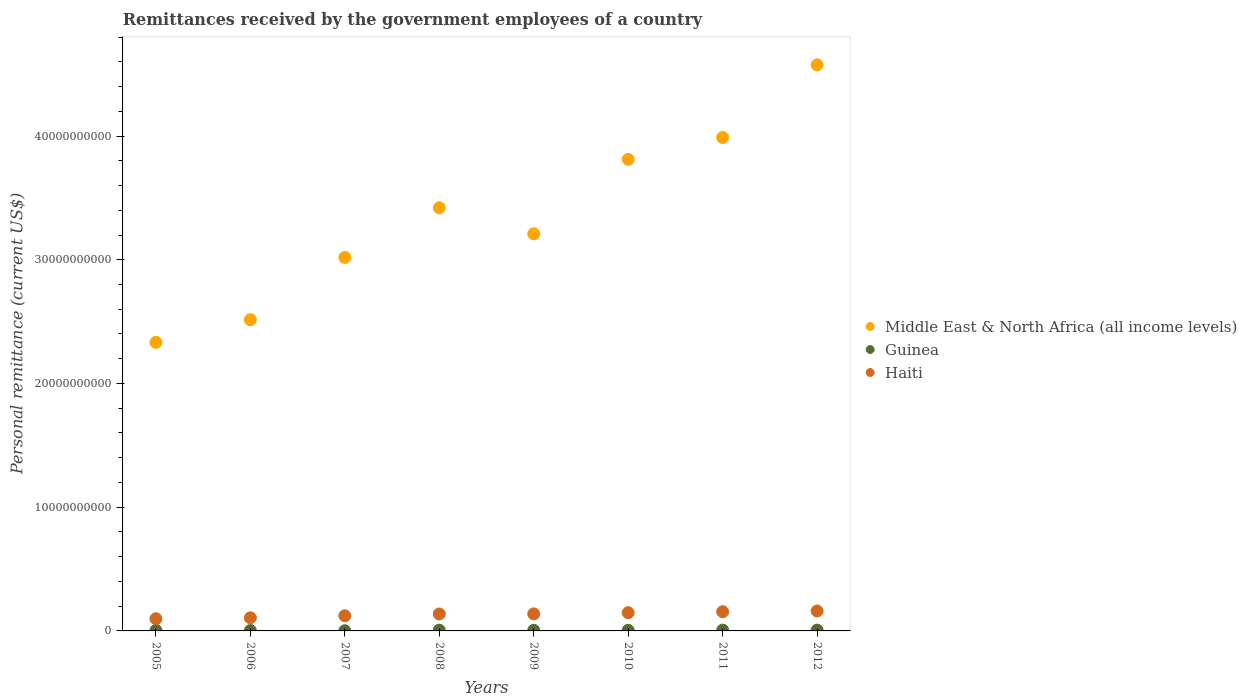What is the remittances received by the government employees in Middle East & North Africa (all income levels) in 2010?
Your answer should be very brief. 3.81e+1. Across all years, what is the maximum remittances received by the government employees in Haiti?
Offer a terse response. 1.61e+09. Across all years, what is the minimum remittances received by the government employees in Guinea?
Make the answer very short. 1.51e+07. In which year was the remittances received by the government employees in Middle East & North Africa (all income levels) maximum?
Keep it short and to the point. 2012. What is the total remittances received by the government employees in Haiti in the graph?
Your answer should be compact. 1.07e+1. What is the difference between the remittances received by the government employees in Middle East & North Africa (all income levels) in 2006 and that in 2008?
Provide a short and direct response. -9.05e+09. What is the difference between the remittances received by the government employees in Middle East & North Africa (all income levels) in 2012 and the remittances received by the government employees in Guinea in 2007?
Give a very brief answer. 4.57e+1. What is the average remittances received by the government employees in Guinea per year?
Provide a short and direct response. 4.71e+07. In the year 2010, what is the difference between the remittances received by the government employees in Guinea and remittances received by the government employees in Middle East & North Africa (all income levels)?
Offer a terse response. -3.81e+1. In how many years, is the remittances received by the government employees in Haiti greater than 28000000000 US$?
Offer a very short reply. 0. What is the ratio of the remittances received by the government employees in Guinea in 2007 to that in 2008?
Provide a succinct answer. 0.24. Is the remittances received by the government employees in Haiti in 2006 less than that in 2009?
Provide a short and direct response. Yes. Is the difference between the remittances received by the government employees in Guinea in 2009 and 2010 greater than the difference between the remittances received by the government employees in Middle East & North Africa (all income levels) in 2009 and 2010?
Ensure brevity in your answer.  Yes. What is the difference between the highest and the second highest remittances received by the government employees in Guinea?
Give a very brief answer. 1.80e+06. What is the difference between the highest and the lowest remittances received by the government employees in Middle East & North Africa (all income levels)?
Provide a succinct answer. 2.24e+1. Is the remittances received by the government employees in Guinea strictly greater than the remittances received by the government employees in Middle East & North Africa (all income levels) over the years?
Your response must be concise. No. How many dotlines are there?
Keep it short and to the point. 3. Does the graph contain any zero values?
Give a very brief answer. No. Does the graph contain grids?
Offer a terse response. No. How many legend labels are there?
Your response must be concise. 3. What is the title of the graph?
Make the answer very short. Remittances received by the government employees of a country. What is the label or title of the X-axis?
Your answer should be very brief. Years. What is the label or title of the Y-axis?
Your answer should be compact. Personal remittance (current US$). What is the Personal remittance (current US$) of Middle East & North Africa (all income levels) in 2005?
Make the answer very short. 2.33e+1. What is the Personal remittance (current US$) of Guinea in 2005?
Provide a succinct answer. 4.16e+07. What is the Personal remittance (current US$) of Haiti in 2005?
Keep it short and to the point. 9.86e+08. What is the Personal remittance (current US$) of Middle East & North Africa (all income levels) in 2006?
Your response must be concise. 2.52e+1. What is the Personal remittance (current US$) in Guinea in 2006?
Your response must be concise. 2.95e+07. What is the Personal remittance (current US$) of Haiti in 2006?
Provide a short and direct response. 1.06e+09. What is the Personal remittance (current US$) in Middle East & North Africa (all income levels) in 2007?
Your response must be concise. 3.02e+1. What is the Personal remittance (current US$) of Guinea in 2007?
Provide a short and direct response. 1.51e+07. What is the Personal remittance (current US$) of Haiti in 2007?
Give a very brief answer. 1.22e+09. What is the Personal remittance (current US$) in Middle East & North Africa (all income levels) in 2008?
Provide a short and direct response. 3.42e+1. What is the Personal remittance (current US$) of Guinea in 2008?
Provide a short and direct response. 6.15e+07. What is the Personal remittance (current US$) of Haiti in 2008?
Make the answer very short. 1.37e+09. What is the Personal remittance (current US$) of Middle East & North Africa (all income levels) in 2009?
Provide a short and direct response. 3.21e+1. What is the Personal remittance (current US$) of Guinea in 2009?
Ensure brevity in your answer.  5.20e+07. What is the Personal remittance (current US$) in Haiti in 2009?
Offer a very short reply. 1.38e+09. What is the Personal remittance (current US$) in Middle East & North Africa (all income levels) in 2010?
Your response must be concise. 3.81e+1. What is the Personal remittance (current US$) of Guinea in 2010?
Make the answer very short. 4.63e+07. What is the Personal remittance (current US$) of Haiti in 2010?
Keep it short and to the point. 1.47e+09. What is the Personal remittance (current US$) of Middle East & North Africa (all income levels) in 2011?
Offer a very short reply. 3.99e+1. What is the Personal remittance (current US$) of Guinea in 2011?
Your answer should be compact. 6.45e+07. What is the Personal remittance (current US$) in Haiti in 2011?
Your answer should be very brief. 1.55e+09. What is the Personal remittance (current US$) of Middle East & North Africa (all income levels) in 2012?
Make the answer very short. 4.58e+1. What is the Personal remittance (current US$) in Guinea in 2012?
Provide a short and direct response. 6.63e+07. What is the Personal remittance (current US$) of Haiti in 2012?
Offer a very short reply. 1.61e+09. Across all years, what is the maximum Personal remittance (current US$) in Middle East & North Africa (all income levels)?
Offer a terse response. 4.58e+1. Across all years, what is the maximum Personal remittance (current US$) in Guinea?
Make the answer very short. 6.63e+07. Across all years, what is the maximum Personal remittance (current US$) of Haiti?
Offer a very short reply. 1.61e+09. Across all years, what is the minimum Personal remittance (current US$) of Middle East & North Africa (all income levels)?
Ensure brevity in your answer.  2.33e+1. Across all years, what is the minimum Personal remittance (current US$) of Guinea?
Offer a very short reply. 1.51e+07. Across all years, what is the minimum Personal remittance (current US$) of Haiti?
Offer a terse response. 9.86e+08. What is the total Personal remittance (current US$) in Middle East & North Africa (all income levels) in the graph?
Your answer should be compact. 2.69e+11. What is the total Personal remittance (current US$) in Guinea in the graph?
Your answer should be compact. 3.77e+08. What is the total Personal remittance (current US$) in Haiti in the graph?
Your answer should be compact. 1.07e+1. What is the difference between the Personal remittance (current US$) of Middle East & North Africa (all income levels) in 2005 and that in 2006?
Your answer should be very brief. -1.83e+09. What is the difference between the Personal remittance (current US$) in Guinea in 2005 and that in 2006?
Provide a short and direct response. 1.21e+07. What is the difference between the Personal remittance (current US$) in Haiti in 2005 and that in 2006?
Provide a short and direct response. -7.67e+07. What is the difference between the Personal remittance (current US$) of Middle East & North Africa (all income levels) in 2005 and that in 2007?
Offer a very short reply. -6.86e+09. What is the difference between the Personal remittance (current US$) in Guinea in 2005 and that in 2007?
Ensure brevity in your answer.  2.65e+07. What is the difference between the Personal remittance (current US$) in Haiti in 2005 and that in 2007?
Ensure brevity in your answer.  -2.36e+08. What is the difference between the Personal remittance (current US$) in Middle East & North Africa (all income levels) in 2005 and that in 2008?
Your answer should be very brief. -1.09e+1. What is the difference between the Personal remittance (current US$) in Guinea in 2005 and that in 2008?
Offer a terse response. -2.00e+07. What is the difference between the Personal remittance (current US$) of Haiti in 2005 and that in 2008?
Make the answer very short. -3.84e+08. What is the difference between the Personal remittance (current US$) in Middle East & North Africa (all income levels) in 2005 and that in 2009?
Your answer should be very brief. -8.77e+09. What is the difference between the Personal remittance (current US$) of Guinea in 2005 and that in 2009?
Provide a succinct answer. -1.05e+07. What is the difference between the Personal remittance (current US$) of Haiti in 2005 and that in 2009?
Give a very brief answer. -3.89e+08. What is the difference between the Personal remittance (current US$) in Middle East & North Africa (all income levels) in 2005 and that in 2010?
Provide a succinct answer. -1.48e+1. What is the difference between the Personal remittance (current US$) in Guinea in 2005 and that in 2010?
Offer a terse response. -4.69e+06. What is the difference between the Personal remittance (current US$) in Haiti in 2005 and that in 2010?
Keep it short and to the point. -4.88e+08. What is the difference between the Personal remittance (current US$) of Middle East & North Africa (all income levels) in 2005 and that in 2011?
Provide a succinct answer. -1.66e+1. What is the difference between the Personal remittance (current US$) of Guinea in 2005 and that in 2011?
Your response must be concise. -2.29e+07. What is the difference between the Personal remittance (current US$) in Haiti in 2005 and that in 2011?
Your answer should be very brief. -5.65e+08. What is the difference between the Personal remittance (current US$) in Middle East & North Africa (all income levels) in 2005 and that in 2012?
Make the answer very short. -2.24e+1. What is the difference between the Personal remittance (current US$) of Guinea in 2005 and that in 2012?
Offer a very short reply. -2.47e+07. What is the difference between the Personal remittance (current US$) in Haiti in 2005 and that in 2012?
Keep it short and to the point. -6.26e+08. What is the difference between the Personal remittance (current US$) in Middle East & North Africa (all income levels) in 2006 and that in 2007?
Give a very brief answer. -5.03e+09. What is the difference between the Personal remittance (current US$) in Guinea in 2006 and that in 2007?
Keep it short and to the point. 1.44e+07. What is the difference between the Personal remittance (current US$) of Haiti in 2006 and that in 2007?
Offer a very short reply. -1.59e+08. What is the difference between the Personal remittance (current US$) of Middle East & North Africa (all income levels) in 2006 and that in 2008?
Provide a short and direct response. -9.05e+09. What is the difference between the Personal remittance (current US$) of Guinea in 2006 and that in 2008?
Your answer should be very brief. -3.20e+07. What is the difference between the Personal remittance (current US$) in Haiti in 2006 and that in 2008?
Make the answer very short. -3.07e+08. What is the difference between the Personal remittance (current US$) in Middle East & North Africa (all income levels) in 2006 and that in 2009?
Provide a succinct answer. -6.95e+09. What is the difference between the Personal remittance (current US$) in Guinea in 2006 and that in 2009?
Your response must be concise. -2.25e+07. What is the difference between the Personal remittance (current US$) of Haiti in 2006 and that in 2009?
Your answer should be compact. -3.13e+08. What is the difference between the Personal remittance (current US$) in Middle East & North Africa (all income levels) in 2006 and that in 2010?
Ensure brevity in your answer.  -1.30e+1. What is the difference between the Personal remittance (current US$) in Guinea in 2006 and that in 2010?
Your answer should be very brief. -1.68e+07. What is the difference between the Personal remittance (current US$) in Haiti in 2006 and that in 2010?
Your answer should be compact. -4.11e+08. What is the difference between the Personal remittance (current US$) of Middle East & North Africa (all income levels) in 2006 and that in 2011?
Offer a terse response. -1.47e+1. What is the difference between the Personal remittance (current US$) in Guinea in 2006 and that in 2011?
Offer a terse response. -3.50e+07. What is the difference between the Personal remittance (current US$) in Haiti in 2006 and that in 2011?
Provide a succinct answer. -4.88e+08. What is the difference between the Personal remittance (current US$) of Middle East & North Africa (all income levels) in 2006 and that in 2012?
Your response must be concise. -2.06e+1. What is the difference between the Personal remittance (current US$) of Guinea in 2006 and that in 2012?
Your answer should be very brief. -3.68e+07. What is the difference between the Personal remittance (current US$) in Haiti in 2006 and that in 2012?
Keep it short and to the point. -5.49e+08. What is the difference between the Personal remittance (current US$) of Middle East & North Africa (all income levels) in 2007 and that in 2008?
Provide a succinct answer. -4.01e+09. What is the difference between the Personal remittance (current US$) in Guinea in 2007 and that in 2008?
Keep it short and to the point. -4.64e+07. What is the difference between the Personal remittance (current US$) of Haiti in 2007 and that in 2008?
Your answer should be very brief. -1.48e+08. What is the difference between the Personal remittance (current US$) in Middle East & North Africa (all income levels) in 2007 and that in 2009?
Ensure brevity in your answer.  -1.91e+09. What is the difference between the Personal remittance (current US$) in Guinea in 2007 and that in 2009?
Provide a succinct answer. -3.70e+07. What is the difference between the Personal remittance (current US$) of Haiti in 2007 and that in 2009?
Provide a short and direct response. -1.53e+08. What is the difference between the Personal remittance (current US$) in Middle East & North Africa (all income levels) in 2007 and that in 2010?
Keep it short and to the point. -7.93e+09. What is the difference between the Personal remittance (current US$) in Guinea in 2007 and that in 2010?
Make the answer very short. -3.12e+07. What is the difference between the Personal remittance (current US$) of Haiti in 2007 and that in 2010?
Ensure brevity in your answer.  -2.52e+08. What is the difference between the Personal remittance (current US$) in Middle East & North Africa (all income levels) in 2007 and that in 2011?
Provide a succinct answer. -9.70e+09. What is the difference between the Personal remittance (current US$) of Guinea in 2007 and that in 2011?
Offer a terse response. -4.94e+07. What is the difference between the Personal remittance (current US$) of Haiti in 2007 and that in 2011?
Your answer should be very brief. -3.29e+08. What is the difference between the Personal remittance (current US$) in Middle East & North Africa (all income levels) in 2007 and that in 2012?
Offer a terse response. -1.56e+1. What is the difference between the Personal remittance (current US$) of Guinea in 2007 and that in 2012?
Your response must be concise. -5.12e+07. What is the difference between the Personal remittance (current US$) of Haiti in 2007 and that in 2012?
Provide a short and direct response. -3.90e+08. What is the difference between the Personal remittance (current US$) in Middle East & North Africa (all income levels) in 2008 and that in 2009?
Your answer should be very brief. 2.10e+09. What is the difference between the Personal remittance (current US$) in Guinea in 2008 and that in 2009?
Provide a succinct answer. 9.49e+06. What is the difference between the Personal remittance (current US$) of Haiti in 2008 and that in 2009?
Ensure brevity in your answer.  -5.79e+06. What is the difference between the Personal remittance (current US$) in Middle East & North Africa (all income levels) in 2008 and that in 2010?
Ensure brevity in your answer.  -3.91e+09. What is the difference between the Personal remittance (current US$) in Guinea in 2008 and that in 2010?
Offer a very short reply. 1.53e+07. What is the difference between the Personal remittance (current US$) in Haiti in 2008 and that in 2010?
Your response must be concise. -1.04e+08. What is the difference between the Personal remittance (current US$) in Middle East & North Africa (all income levels) in 2008 and that in 2011?
Give a very brief answer. -5.68e+09. What is the difference between the Personal remittance (current US$) in Guinea in 2008 and that in 2011?
Ensure brevity in your answer.  -2.98e+06. What is the difference between the Personal remittance (current US$) in Haiti in 2008 and that in 2011?
Your answer should be very brief. -1.82e+08. What is the difference between the Personal remittance (current US$) in Middle East & North Africa (all income levels) in 2008 and that in 2012?
Your answer should be compact. -1.16e+1. What is the difference between the Personal remittance (current US$) of Guinea in 2008 and that in 2012?
Provide a short and direct response. -4.78e+06. What is the difference between the Personal remittance (current US$) of Haiti in 2008 and that in 2012?
Offer a terse response. -2.43e+08. What is the difference between the Personal remittance (current US$) of Middle East & North Africa (all income levels) in 2009 and that in 2010?
Offer a terse response. -6.02e+09. What is the difference between the Personal remittance (current US$) in Guinea in 2009 and that in 2010?
Provide a succinct answer. 5.77e+06. What is the difference between the Personal remittance (current US$) in Haiti in 2009 and that in 2010?
Offer a terse response. -9.83e+07. What is the difference between the Personal remittance (current US$) of Middle East & North Africa (all income levels) in 2009 and that in 2011?
Provide a succinct answer. -7.79e+09. What is the difference between the Personal remittance (current US$) in Guinea in 2009 and that in 2011?
Your answer should be compact. -1.25e+07. What is the difference between the Personal remittance (current US$) of Haiti in 2009 and that in 2011?
Ensure brevity in your answer.  -1.76e+08. What is the difference between the Personal remittance (current US$) in Middle East & North Africa (all income levels) in 2009 and that in 2012?
Make the answer very short. -1.37e+1. What is the difference between the Personal remittance (current US$) of Guinea in 2009 and that in 2012?
Your answer should be compact. -1.43e+07. What is the difference between the Personal remittance (current US$) of Haiti in 2009 and that in 2012?
Make the answer very short. -2.37e+08. What is the difference between the Personal remittance (current US$) of Middle East & North Africa (all income levels) in 2010 and that in 2011?
Your answer should be very brief. -1.77e+09. What is the difference between the Personal remittance (current US$) in Guinea in 2010 and that in 2011?
Your answer should be compact. -1.82e+07. What is the difference between the Personal remittance (current US$) in Haiti in 2010 and that in 2011?
Make the answer very short. -7.76e+07. What is the difference between the Personal remittance (current US$) of Middle East & North Africa (all income levels) in 2010 and that in 2012?
Ensure brevity in your answer.  -7.64e+09. What is the difference between the Personal remittance (current US$) of Guinea in 2010 and that in 2012?
Make the answer very short. -2.00e+07. What is the difference between the Personal remittance (current US$) of Haiti in 2010 and that in 2012?
Provide a succinct answer. -1.39e+08. What is the difference between the Personal remittance (current US$) in Middle East & North Africa (all income levels) in 2011 and that in 2012?
Ensure brevity in your answer.  -5.87e+09. What is the difference between the Personal remittance (current US$) in Guinea in 2011 and that in 2012?
Your response must be concise. -1.80e+06. What is the difference between the Personal remittance (current US$) in Haiti in 2011 and that in 2012?
Give a very brief answer. -6.10e+07. What is the difference between the Personal remittance (current US$) of Middle East & North Africa (all income levels) in 2005 and the Personal remittance (current US$) of Guinea in 2006?
Ensure brevity in your answer.  2.33e+1. What is the difference between the Personal remittance (current US$) in Middle East & North Africa (all income levels) in 2005 and the Personal remittance (current US$) in Haiti in 2006?
Make the answer very short. 2.23e+1. What is the difference between the Personal remittance (current US$) in Guinea in 2005 and the Personal remittance (current US$) in Haiti in 2006?
Keep it short and to the point. -1.02e+09. What is the difference between the Personal remittance (current US$) in Middle East & North Africa (all income levels) in 2005 and the Personal remittance (current US$) in Guinea in 2007?
Offer a terse response. 2.33e+1. What is the difference between the Personal remittance (current US$) in Middle East & North Africa (all income levels) in 2005 and the Personal remittance (current US$) in Haiti in 2007?
Offer a very short reply. 2.21e+1. What is the difference between the Personal remittance (current US$) of Guinea in 2005 and the Personal remittance (current US$) of Haiti in 2007?
Offer a very short reply. -1.18e+09. What is the difference between the Personal remittance (current US$) in Middle East & North Africa (all income levels) in 2005 and the Personal remittance (current US$) in Guinea in 2008?
Your response must be concise. 2.33e+1. What is the difference between the Personal remittance (current US$) of Middle East & North Africa (all income levels) in 2005 and the Personal remittance (current US$) of Haiti in 2008?
Your answer should be compact. 2.20e+1. What is the difference between the Personal remittance (current US$) in Guinea in 2005 and the Personal remittance (current US$) in Haiti in 2008?
Keep it short and to the point. -1.33e+09. What is the difference between the Personal remittance (current US$) in Middle East & North Africa (all income levels) in 2005 and the Personal remittance (current US$) in Guinea in 2009?
Keep it short and to the point. 2.33e+1. What is the difference between the Personal remittance (current US$) in Middle East & North Africa (all income levels) in 2005 and the Personal remittance (current US$) in Haiti in 2009?
Provide a succinct answer. 2.20e+1. What is the difference between the Personal remittance (current US$) in Guinea in 2005 and the Personal remittance (current US$) in Haiti in 2009?
Offer a very short reply. -1.33e+09. What is the difference between the Personal remittance (current US$) in Middle East & North Africa (all income levels) in 2005 and the Personal remittance (current US$) in Guinea in 2010?
Make the answer very short. 2.33e+1. What is the difference between the Personal remittance (current US$) in Middle East & North Africa (all income levels) in 2005 and the Personal remittance (current US$) in Haiti in 2010?
Give a very brief answer. 2.19e+1. What is the difference between the Personal remittance (current US$) of Guinea in 2005 and the Personal remittance (current US$) of Haiti in 2010?
Offer a terse response. -1.43e+09. What is the difference between the Personal remittance (current US$) in Middle East & North Africa (all income levels) in 2005 and the Personal remittance (current US$) in Guinea in 2011?
Provide a short and direct response. 2.33e+1. What is the difference between the Personal remittance (current US$) in Middle East & North Africa (all income levels) in 2005 and the Personal remittance (current US$) in Haiti in 2011?
Your response must be concise. 2.18e+1. What is the difference between the Personal remittance (current US$) in Guinea in 2005 and the Personal remittance (current US$) in Haiti in 2011?
Your answer should be very brief. -1.51e+09. What is the difference between the Personal remittance (current US$) in Middle East & North Africa (all income levels) in 2005 and the Personal remittance (current US$) in Guinea in 2012?
Ensure brevity in your answer.  2.33e+1. What is the difference between the Personal remittance (current US$) of Middle East & North Africa (all income levels) in 2005 and the Personal remittance (current US$) of Haiti in 2012?
Your answer should be very brief. 2.17e+1. What is the difference between the Personal remittance (current US$) of Guinea in 2005 and the Personal remittance (current US$) of Haiti in 2012?
Offer a very short reply. -1.57e+09. What is the difference between the Personal remittance (current US$) in Middle East & North Africa (all income levels) in 2006 and the Personal remittance (current US$) in Guinea in 2007?
Offer a very short reply. 2.51e+1. What is the difference between the Personal remittance (current US$) of Middle East & North Africa (all income levels) in 2006 and the Personal remittance (current US$) of Haiti in 2007?
Offer a terse response. 2.39e+1. What is the difference between the Personal remittance (current US$) in Guinea in 2006 and the Personal remittance (current US$) in Haiti in 2007?
Give a very brief answer. -1.19e+09. What is the difference between the Personal remittance (current US$) of Middle East & North Africa (all income levels) in 2006 and the Personal remittance (current US$) of Guinea in 2008?
Make the answer very short. 2.51e+1. What is the difference between the Personal remittance (current US$) of Middle East & North Africa (all income levels) in 2006 and the Personal remittance (current US$) of Haiti in 2008?
Make the answer very short. 2.38e+1. What is the difference between the Personal remittance (current US$) in Guinea in 2006 and the Personal remittance (current US$) in Haiti in 2008?
Give a very brief answer. -1.34e+09. What is the difference between the Personal remittance (current US$) in Middle East & North Africa (all income levels) in 2006 and the Personal remittance (current US$) in Guinea in 2009?
Your response must be concise. 2.51e+1. What is the difference between the Personal remittance (current US$) in Middle East & North Africa (all income levels) in 2006 and the Personal remittance (current US$) in Haiti in 2009?
Your answer should be compact. 2.38e+1. What is the difference between the Personal remittance (current US$) of Guinea in 2006 and the Personal remittance (current US$) of Haiti in 2009?
Your answer should be very brief. -1.35e+09. What is the difference between the Personal remittance (current US$) of Middle East & North Africa (all income levels) in 2006 and the Personal remittance (current US$) of Guinea in 2010?
Ensure brevity in your answer.  2.51e+1. What is the difference between the Personal remittance (current US$) of Middle East & North Africa (all income levels) in 2006 and the Personal remittance (current US$) of Haiti in 2010?
Your answer should be very brief. 2.37e+1. What is the difference between the Personal remittance (current US$) of Guinea in 2006 and the Personal remittance (current US$) of Haiti in 2010?
Make the answer very short. -1.44e+09. What is the difference between the Personal remittance (current US$) in Middle East & North Africa (all income levels) in 2006 and the Personal remittance (current US$) in Guinea in 2011?
Offer a very short reply. 2.51e+1. What is the difference between the Personal remittance (current US$) of Middle East & North Africa (all income levels) in 2006 and the Personal remittance (current US$) of Haiti in 2011?
Your answer should be compact. 2.36e+1. What is the difference between the Personal remittance (current US$) of Guinea in 2006 and the Personal remittance (current US$) of Haiti in 2011?
Your response must be concise. -1.52e+09. What is the difference between the Personal remittance (current US$) of Middle East & North Africa (all income levels) in 2006 and the Personal remittance (current US$) of Guinea in 2012?
Provide a short and direct response. 2.51e+1. What is the difference between the Personal remittance (current US$) in Middle East & North Africa (all income levels) in 2006 and the Personal remittance (current US$) in Haiti in 2012?
Keep it short and to the point. 2.35e+1. What is the difference between the Personal remittance (current US$) in Guinea in 2006 and the Personal remittance (current US$) in Haiti in 2012?
Provide a succinct answer. -1.58e+09. What is the difference between the Personal remittance (current US$) in Middle East & North Africa (all income levels) in 2007 and the Personal remittance (current US$) in Guinea in 2008?
Provide a succinct answer. 3.01e+1. What is the difference between the Personal remittance (current US$) of Middle East & North Africa (all income levels) in 2007 and the Personal remittance (current US$) of Haiti in 2008?
Offer a terse response. 2.88e+1. What is the difference between the Personal remittance (current US$) in Guinea in 2007 and the Personal remittance (current US$) in Haiti in 2008?
Offer a terse response. -1.35e+09. What is the difference between the Personal remittance (current US$) of Middle East & North Africa (all income levels) in 2007 and the Personal remittance (current US$) of Guinea in 2009?
Offer a terse response. 3.01e+1. What is the difference between the Personal remittance (current US$) of Middle East & North Africa (all income levels) in 2007 and the Personal remittance (current US$) of Haiti in 2009?
Your answer should be compact. 2.88e+1. What is the difference between the Personal remittance (current US$) in Guinea in 2007 and the Personal remittance (current US$) in Haiti in 2009?
Offer a terse response. -1.36e+09. What is the difference between the Personal remittance (current US$) of Middle East & North Africa (all income levels) in 2007 and the Personal remittance (current US$) of Guinea in 2010?
Your response must be concise. 3.01e+1. What is the difference between the Personal remittance (current US$) of Middle East & North Africa (all income levels) in 2007 and the Personal remittance (current US$) of Haiti in 2010?
Ensure brevity in your answer.  2.87e+1. What is the difference between the Personal remittance (current US$) in Guinea in 2007 and the Personal remittance (current US$) in Haiti in 2010?
Provide a succinct answer. -1.46e+09. What is the difference between the Personal remittance (current US$) of Middle East & North Africa (all income levels) in 2007 and the Personal remittance (current US$) of Guinea in 2011?
Provide a succinct answer. 3.01e+1. What is the difference between the Personal remittance (current US$) in Middle East & North Africa (all income levels) in 2007 and the Personal remittance (current US$) in Haiti in 2011?
Keep it short and to the point. 2.86e+1. What is the difference between the Personal remittance (current US$) of Guinea in 2007 and the Personal remittance (current US$) of Haiti in 2011?
Your response must be concise. -1.54e+09. What is the difference between the Personal remittance (current US$) of Middle East & North Africa (all income levels) in 2007 and the Personal remittance (current US$) of Guinea in 2012?
Your answer should be very brief. 3.01e+1. What is the difference between the Personal remittance (current US$) of Middle East & North Africa (all income levels) in 2007 and the Personal remittance (current US$) of Haiti in 2012?
Give a very brief answer. 2.86e+1. What is the difference between the Personal remittance (current US$) of Guinea in 2007 and the Personal remittance (current US$) of Haiti in 2012?
Provide a short and direct response. -1.60e+09. What is the difference between the Personal remittance (current US$) of Middle East & North Africa (all income levels) in 2008 and the Personal remittance (current US$) of Guinea in 2009?
Keep it short and to the point. 3.41e+1. What is the difference between the Personal remittance (current US$) in Middle East & North Africa (all income levels) in 2008 and the Personal remittance (current US$) in Haiti in 2009?
Offer a terse response. 3.28e+1. What is the difference between the Personal remittance (current US$) in Guinea in 2008 and the Personal remittance (current US$) in Haiti in 2009?
Your answer should be very brief. -1.31e+09. What is the difference between the Personal remittance (current US$) in Middle East & North Africa (all income levels) in 2008 and the Personal remittance (current US$) in Guinea in 2010?
Your answer should be very brief. 3.42e+1. What is the difference between the Personal remittance (current US$) in Middle East & North Africa (all income levels) in 2008 and the Personal remittance (current US$) in Haiti in 2010?
Provide a short and direct response. 3.27e+1. What is the difference between the Personal remittance (current US$) in Guinea in 2008 and the Personal remittance (current US$) in Haiti in 2010?
Provide a short and direct response. -1.41e+09. What is the difference between the Personal remittance (current US$) in Middle East & North Africa (all income levels) in 2008 and the Personal remittance (current US$) in Guinea in 2011?
Your answer should be very brief. 3.41e+1. What is the difference between the Personal remittance (current US$) in Middle East & North Africa (all income levels) in 2008 and the Personal remittance (current US$) in Haiti in 2011?
Your answer should be very brief. 3.26e+1. What is the difference between the Personal remittance (current US$) of Guinea in 2008 and the Personal remittance (current US$) of Haiti in 2011?
Ensure brevity in your answer.  -1.49e+09. What is the difference between the Personal remittance (current US$) in Middle East & North Africa (all income levels) in 2008 and the Personal remittance (current US$) in Guinea in 2012?
Provide a short and direct response. 3.41e+1. What is the difference between the Personal remittance (current US$) in Middle East & North Africa (all income levels) in 2008 and the Personal remittance (current US$) in Haiti in 2012?
Your response must be concise. 3.26e+1. What is the difference between the Personal remittance (current US$) of Guinea in 2008 and the Personal remittance (current US$) of Haiti in 2012?
Your answer should be very brief. -1.55e+09. What is the difference between the Personal remittance (current US$) of Middle East & North Africa (all income levels) in 2009 and the Personal remittance (current US$) of Guinea in 2010?
Your answer should be compact. 3.21e+1. What is the difference between the Personal remittance (current US$) in Middle East & North Africa (all income levels) in 2009 and the Personal remittance (current US$) in Haiti in 2010?
Offer a very short reply. 3.06e+1. What is the difference between the Personal remittance (current US$) in Guinea in 2009 and the Personal remittance (current US$) in Haiti in 2010?
Provide a short and direct response. -1.42e+09. What is the difference between the Personal remittance (current US$) in Middle East & North Africa (all income levels) in 2009 and the Personal remittance (current US$) in Guinea in 2011?
Keep it short and to the point. 3.20e+1. What is the difference between the Personal remittance (current US$) in Middle East & North Africa (all income levels) in 2009 and the Personal remittance (current US$) in Haiti in 2011?
Your response must be concise. 3.05e+1. What is the difference between the Personal remittance (current US$) of Guinea in 2009 and the Personal remittance (current US$) of Haiti in 2011?
Provide a succinct answer. -1.50e+09. What is the difference between the Personal remittance (current US$) in Middle East & North Africa (all income levels) in 2009 and the Personal remittance (current US$) in Guinea in 2012?
Offer a very short reply. 3.20e+1. What is the difference between the Personal remittance (current US$) of Middle East & North Africa (all income levels) in 2009 and the Personal remittance (current US$) of Haiti in 2012?
Your answer should be compact. 3.05e+1. What is the difference between the Personal remittance (current US$) in Guinea in 2009 and the Personal remittance (current US$) in Haiti in 2012?
Provide a short and direct response. -1.56e+09. What is the difference between the Personal remittance (current US$) of Middle East & North Africa (all income levels) in 2010 and the Personal remittance (current US$) of Guinea in 2011?
Your response must be concise. 3.80e+1. What is the difference between the Personal remittance (current US$) in Middle East & North Africa (all income levels) in 2010 and the Personal remittance (current US$) in Haiti in 2011?
Ensure brevity in your answer.  3.66e+1. What is the difference between the Personal remittance (current US$) in Guinea in 2010 and the Personal remittance (current US$) in Haiti in 2011?
Your response must be concise. -1.51e+09. What is the difference between the Personal remittance (current US$) of Middle East & North Africa (all income levels) in 2010 and the Personal remittance (current US$) of Guinea in 2012?
Offer a terse response. 3.80e+1. What is the difference between the Personal remittance (current US$) in Middle East & North Africa (all income levels) in 2010 and the Personal remittance (current US$) in Haiti in 2012?
Keep it short and to the point. 3.65e+1. What is the difference between the Personal remittance (current US$) of Guinea in 2010 and the Personal remittance (current US$) of Haiti in 2012?
Your answer should be compact. -1.57e+09. What is the difference between the Personal remittance (current US$) in Middle East & North Africa (all income levels) in 2011 and the Personal remittance (current US$) in Guinea in 2012?
Ensure brevity in your answer.  3.98e+1. What is the difference between the Personal remittance (current US$) of Middle East & North Africa (all income levels) in 2011 and the Personal remittance (current US$) of Haiti in 2012?
Your answer should be compact. 3.83e+1. What is the difference between the Personal remittance (current US$) of Guinea in 2011 and the Personal remittance (current US$) of Haiti in 2012?
Your answer should be very brief. -1.55e+09. What is the average Personal remittance (current US$) in Middle East & North Africa (all income levels) per year?
Make the answer very short. 3.36e+1. What is the average Personal remittance (current US$) of Guinea per year?
Offer a terse response. 4.71e+07. What is the average Personal remittance (current US$) of Haiti per year?
Your answer should be very brief. 1.33e+09. In the year 2005, what is the difference between the Personal remittance (current US$) in Middle East & North Africa (all income levels) and Personal remittance (current US$) in Guinea?
Your answer should be very brief. 2.33e+1. In the year 2005, what is the difference between the Personal remittance (current US$) in Middle East & North Africa (all income levels) and Personal remittance (current US$) in Haiti?
Your answer should be very brief. 2.23e+1. In the year 2005, what is the difference between the Personal remittance (current US$) of Guinea and Personal remittance (current US$) of Haiti?
Your answer should be compact. -9.45e+08. In the year 2006, what is the difference between the Personal remittance (current US$) in Middle East & North Africa (all income levels) and Personal remittance (current US$) in Guinea?
Your answer should be compact. 2.51e+1. In the year 2006, what is the difference between the Personal remittance (current US$) in Middle East & North Africa (all income levels) and Personal remittance (current US$) in Haiti?
Your answer should be compact. 2.41e+1. In the year 2006, what is the difference between the Personal remittance (current US$) in Guinea and Personal remittance (current US$) in Haiti?
Your answer should be compact. -1.03e+09. In the year 2007, what is the difference between the Personal remittance (current US$) of Middle East & North Africa (all income levels) and Personal remittance (current US$) of Guinea?
Provide a succinct answer. 3.02e+1. In the year 2007, what is the difference between the Personal remittance (current US$) of Middle East & North Africa (all income levels) and Personal remittance (current US$) of Haiti?
Provide a short and direct response. 2.90e+1. In the year 2007, what is the difference between the Personal remittance (current US$) in Guinea and Personal remittance (current US$) in Haiti?
Offer a very short reply. -1.21e+09. In the year 2008, what is the difference between the Personal remittance (current US$) of Middle East & North Africa (all income levels) and Personal remittance (current US$) of Guinea?
Your answer should be compact. 3.41e+1. In the year 2008, what is the difference between the Personal remittance (current US$) in Middle East & North Africa (all income levels) and Personal remittance (current US$) in Haiti?
Your answer should be compact. 3.28e+1. In the year 2008, what is the difference between the Personal remittance (current US$) in Guinea and Personal remittance (current US$) in Haiti?
Keep it short and to the point. -1.31e+09. In the year 2009, what is the difference between the Personal remittance (current US$) of Middle East & North Africa (all income levels) and Personal remittance (current US$) of Guinea?
Offer a terse response. 3.20e+1. In the year 2009, what is the difference between the Personal remittance (current US$) of Middle East & North Africa (all income levels) and Personal remittance (current US$) of Haiti?
Give a very brief answer. 3.07e+1. In the year 2009, what is the difference between the Personal remittance (current US$) in Guinea and Personal remittance (current US$) in Haiti?
Ensure brevity in your answer.  -1.32e+09. In the year 2010, what is the difference between the Personal remittance (current US$) in Middle East & North Africa (all income levels) and Personal remittance (current US$) in Guinea?
Your response must be concise. 3.81e+1. In the year 2010, what is the difference between the Personal remittance (current US$) of Middle East & North Africa (all income levels) and Personal remittance (current US$) of Haiti?
Provide a short and direct response. 3.66e+1. In the year 2010, what is the difference between the Personal remittance (current US$) in Guinea and Personal remittance (current US$) in Haiti?
Your response must be concise. -1.43e+09. In the year 2011, what is the difference between the Personal remittance (current US$) in Middle East & North Africa (all income levels) and Personal remittance (current US$) in Guinea?
Ensure brevity in your answer.  3.98e+1. In the year 2011, what is the difference between the Personal remittance (current US$) of Middle East & North Africa (all income levels) and Personal remittance (current US$) of Haiti?
Offer a very short reply. 3.83e+1. In the year 2011, what is the difference between the Personal remittance (current US$) in Guinea and Personal remittance (current US$) in Haiti?
Offer a very short reply. -1.49e+09. In the year 2012, what is the difference between the Personal remittance (current US$) in Middle East & North Africa (all income levels) and Personal remittance (current US$) in Guinea?
Your answer should be very brief. 4.57e+1. In the year 2012, what is the difference between the Personal remittance (current US$) in Middle East & North Africa (all income levels) and Personal remittance (current US$) in Haiti?
Offer a very short reply. 4.41e+1. In the year 2012, what is the difference between the Personal remittance (current US$) in Guinea and Personal remittance (current US$) in Haiti?
Your response must be concise. -1.55e+09. What is the ratio of the Personal remittance (current US$) in Middle East & North Africa (all income levels) in 2005 to that in 2006?
Your response must be concise. 0.93. What is the ratio of the Personal remittance (current US$) in Guinea in 2005 to that in 2006?
Your response must be concise. 1.41. What is the ratio of the Personal remittance (current US$) in Haiti in 2005 to that in 2006?
Ensure brevity in your answer.  0.93. What is the ratio of the Personal remittance (current US$) of Middle East & North Africa (all income levels) in 2005 to that in 2007?
Give a very brief answer. 0.77. What is the ratio of the Personal remittance (current US$) of Guinea in 2005 to that in 2007?
Your answer should be compact. 2.76. What is the ratio of the Personal remittance (current US$) of Haiti in 2005 to that in 2007?
Provide a short and direct response. 0.81. What is the ratio of the Personal remittance (current US$) of Middle East & North Africa (all income levels) in 2005 to that in 2008?
Your response must be concise. 0.68. What is the ratio of the Personal remittance (current US$) in Guinea in 2005 to that in 2008?
Offer a terse response. 0.68. What is the ratio of the Personal remittance (current US$) in Haiti in 2005 to that in 2008?
Offer a terse response. 0.72. What is the ratio of the Personal remittance (current US$) in Middle East & North Africa (all income levels) in 2005 to that in 2009?
Offer a very short reply. 0.73. What is the ratio of the Personal remittance (current US$) of Guinea in 2005 to that in 2009?
Your response must be concise. 0.8. What is the ratio of the Personal remittance (current US$) of Haiti in 2005 to that in 2009?
Offer a very short reply. 0.72. What is the ratio of the Personal remittance (current US$) in Middle East & North Africa (all income levels) in 2005 to that in 2010?
Your answer should be very brief. 0.61. What is the ratio of the Personal remittance (current US$) in Guinea in 2005 to that in 2010?
Your answer should be very brief. 0.9. What is the ratio of the Personal remittance (current US$) of Haiti in 2005 to that in 2010?
Provide a succinct answer. 0.67. What is the ratio of the Personal remittance (current US$) of Middle East & North Africa (all income levels) in 2005 to that in 2011?
Your answer should be very brief. 0.58. What is the ratio of the Personal remittance (current US$) in Guinea in 2005 to that in 2011?
Offer a very short reply. 0.64. What is the ratio of the Personal remittance (current US$) in Haiti in 2005 to that in 2011?
Provide a succinct answer. 0.64. What is the ratio of the Personal remittance (current US$) in Middle East & North Africa (all income levels) in 2005 to that in 2012?
Make the answer very short. 0.51. What is the ratio of the Personal remittance (current US$) of Guinea in 2005 to that in 2012?
Offer a very short reply. 0.63. What is the ratio of the Personal remittance (current US$) in Haiti in 2005 to that in 2012?
Make the answer very short. 0.61. What is the ratio of the Personal remittance (current US$) in Middle East & North Africa (all income levels) in 2006 to that in 2007?
Keep it short and to the point. 0.83. What is the ratio of the Personal remittance (current US$) of Guinea in 2006 to that in 2007?
Offer a very short reply. 1.96. What is the ratio of the Personal remittance (current US$) of Haiti in 2006 to that in 2007?
Give a very brief answer. 0.87. What is the ratio of the Personal remittance (current US$) in Middle East & North Africa (all income levels) in 2006 to that in 2008?
Keep it short and to the point. 0.74. What is the ratio of the Personal remittance (current US$) in Guinea in 2006 to that in 2008?
Ensure brevity in your answer.  0.48. What is the ratio of the Personal remittance (current US$) of Haiti in 2006 to that in 2008?
Make the answer very short. 0.78. What is the ratio of the Personal remittance (current US$) in Middle East & North Africa (all income levels) in 2006 to that in 2009?
Your response must be concise. 0.78. What is the ratio of the Personal remittance (current US$) of Guinea in 2006 to that in 2009?
Your response must be concise. 0.57. What is the ratio of the Personal remittance (current US$) of Haiti in 2006 to that in 2009?
Offer a very short reply. 0.77. What is the ratio of the Personal remittance (current US$) of Middle East & North Africa (all income levels) in 2006 to that in 2010?
Your answer should be compact. 0.66. What is the ratio of the Personal remittance (current US$) in Guinea in 2006 to that in 2010?
Provide a succinct answer. 0.64. What is the ratio of the Personal remittance (current US$) in Haiti in 2006 to that in 2010?
Provide a short and direct response. 0.72. What is the ratio of the Personal remittance (current US$) of Middle East & North Africa (all income levels) in 2006 to that in 2011?
Offer a very short reply. 0.63. What is the ratio of the Personal remittance (current US$) in Guinea in 2006 to that in 2011?
Give a very brief answer. 0.46. What is the ratio of the Personal remittance (current US$) of Haiti in 2006 to that in 2011?
Offer a very short reply. 0.69. What is the ratio of the Personal remittance (current US$) in Middle East & North Africa (all income levels) in 2006 to that in 2012?
Give a very brief answer. 0.55. What is the ratio of the Personal remittance (current US$) in Guinea in 2006 to that in 2012?
Ensure brevity in your answer.  0.44. What is the ratio of the Personal remittance (current US$) of Haiti in 2006 to that in 2012?
Your answer should be compact. 0.66. What is the ratio of the Personal remittance (current US$) of Middle East & North Africa (all income levels) in 2007 to that in 2008?
Give a very brief answer. 0.88. What is the ratio of the Personal remittance (current US$) of Guinea in 2007 to that in 2008?
Your answer should be very brief. 0.24. What is the ratio of the Personal remittance (current US$) in Haiti in 2007 to that in 2008?
Make the answer very short. 0.89. What is the ratio of the Personal remittance (current US$) of Middle East & North Africa (all income levels) in 2007 to that in 2009?
Your answer should be compact. 0.94. What is the ratio of the Personal remittance (current US$) of Guinea in 2007 to that in 2009?
Your response must be concise. 0.29. What is the ratio of the Personal remittance (current US$) in Haiti in 2007 to that in 2009?
Your answer should be very brief. 0.89. What is the ratio of the Personal remittance (current US$) in Middle East & North Africa (all income levels) in 2007 to that in 2010?
Provide a short and direct response. 0.79. What is the ratio of the Personal remittance (current US$) in Guinea in 2007 to that in 2010?
Offer a terse response. 0.33. What is the ratio of the Personal remittance (current US$) of Haiti in 2007 to that in 2010?
Keep it short and to the point. 0.83. What is the ratio of the Personal remittance (current US$) in Middle East & North Africa (all income levels) in 2007 to that in 2011?
Your answer should be compact. 0.76. What is the ratio of the Personal remittance (current US$) of Guinea in 2007 to that in 2011?
Keep it short and to the point. 0.23. What is the ratio of the Personal remittance (current US$) of Haiti in 2007 to that in 2011?
Provide a short and direct response. 0.79. What is the ratio of the Personal remittance (current US$) in Middle East & North Africa (all income levels) in 2007 to that in 2012?
Offer a terse response. 0.66. What is the ratio of the Personal remittance (current US$) in Guinea in 2007 to that in 2012?
Your answer should be compact. 0.23. What is the ratio of the Personal remittance (current US$) in Haiti in 2007 to that in 2012?
Offer a terse response. 0.76. What is the ratio of the Personal remittance (current US$) of Middle East & North Africa (all income levels) in 2008 to that in 2009?
Your answer should be very brief. 1.07. What is the ratio of the Personal remittance (current US$) in Guinea in 2008 to that in 2009?
Ensure brevity in your answer.  1.18. What is the ratio of the Personal remittance (current US$) of Haiti in 2008 to that in 2009?
Provide a succinct answer. 1. What is the ratio of the Personal remittance (current US$) in Middle East & North Africa (all income levels) in 2008 to that in 2010?
Your answer should be compact. 0.9. What is the ratio of the Personal remittance (current US$) in Guinea in 2008 to that in 2010?
Your response must be concise. 1.33. What is the ratio of the Personal remittance (current US$) of Haiti in 2008 to that in 2010?
Your answer should be compact. 0.93. What is the ratio of the Personal remittance (current US$) of Middle East & North Africa (all income levels) in 2008 to that in 2011?
Make the answer very short. 0.86. What is the ratio of the Personal remittance (current US$) in Guinea in 2008 to that in 2011?
Keep it short and to the point. 0.95. What is the ratio of the Personal remittance (current US$) of Haiti in 2008 to that in 2011?
Your answer should be very brief. 0.88. What is the ratio of the Personal remittance (current US$) of Middle East & North Africa (all income levels) in 2008 to that in 2012?
Provide a short and direct response. 0.75. What is the ratio of the Personal remittance (current US$) of Guinea in 2008 to that in 2012?
Your answer should be very brief. 0.93. What is the ratio of the Personal remittance (current US$) of Haiti in 2008 to that in 2012?
Offer a terse response. 0.85. What is the ratio of the Personal remittance (current US$) in Middle East & North Africa (all income levels) in 2009 to that in 2010?
Ensure brevity in your answer.  0.84. What is the ratio of the Personal remittance (current US$) in Guinea in 2009 to that in 2010?
Provide a succinct answer. 1.12. What is the ratio of the Personal remittance (current US$) of Haiti in 2009 to that in 2010?
Provide a short and direct response. 0.93. What is the ratio of the Personal remittance (current US$) in Middle East & North Africa (all income levels) in 2009 to that in 2011?
Offer a terse response. 0.8. What is the ratio of the Personal remittance (current US$) of Guinea in 2009 to that in 2011?
Offer a very short reply. 0.81. What is the ratio of the Personal remittance (current US$) of Haiti in 2009 to that in 2011?
Offer a very short reply. 0.89. What is the ratio of the Personal remittance (current US$) in Middle East & North Africa (all income levels) in 2009 to that in 2012?
Provide a short and direct response. 0.7. What is the ratio of the Personal remittance (current US$) of Guinea in 2009 to that in 2012?
Provide a short and direct response. 0.78. What is the ratio of the Personal remittance (current US$) of Haiti in 2009 to that in 2012?
Your response must be concise. 0.85. What is the ratio of the Personal remittance (current US$) in Middle East & North Africa (all income levels) in 2010 to that in 2011?
Offer a very short reply. 0.96. What is the ratio of the Personal remittance (current US$) of Guinea in 2010 to that in 2011?
Your answer should be compact. 0.72. What is the ratio of the Personal remittance (current US$) in Middle East & North Africa (all income levels) in 2010 to that in 2012?
Offer a very short reply. 0.83. What is the ratio of the Personal remittance (current US$) in Guinea in 2010 to that in 2012?
Give a very brief answer. 0.7. What is the ratio of the Personal remittance (current US$) of Haiti in 2010 to that in 2012?
Keep it short and to the point. 0.91. What is the ratio of the Personal remittance (current US$) in Middle East & North Africa (all income levels) in 2011 to that in 2012?
Give a very brief answer. 0.87. What is the ratio of the Personal remittance (current US$) in Guinea in 2011 to that in 2012?
Offer a terse response. 0.97. What is the ratio of the Personal remittance (current US$) of Haiti in 2011 to that in 2012?
Ensure brevity in your answer.  0.96. What is the difference between the highest and the second highest Personal remittance (current US$) in Middle East & North Africa (all income levels)?
Offer a terse response. 5.87e+09. What is the difference between the highest and the second highest Personal remittance (current US$) in Guinea?
Offer a terse response. 1.80e+06. What is the difference between the highest and the second highest Personal remittance (current US$) of Haiti?
Offer a terse response. 6.10e+07. What is the difference between the highest and the lowest Personal remittance (current US$) of Middle East & North Africa (all income levels)?
Keep it short and to the point. 2.24e+1. What is the difference between the highest and the lowest Personal remittance (current US$) in Guinea?
Your answer should be compact. 5.12e+07. What is the difference between the highest and the lowest Personal remittance (current US$) in Haiti?
Offer a terse response. 6.26e+08. 